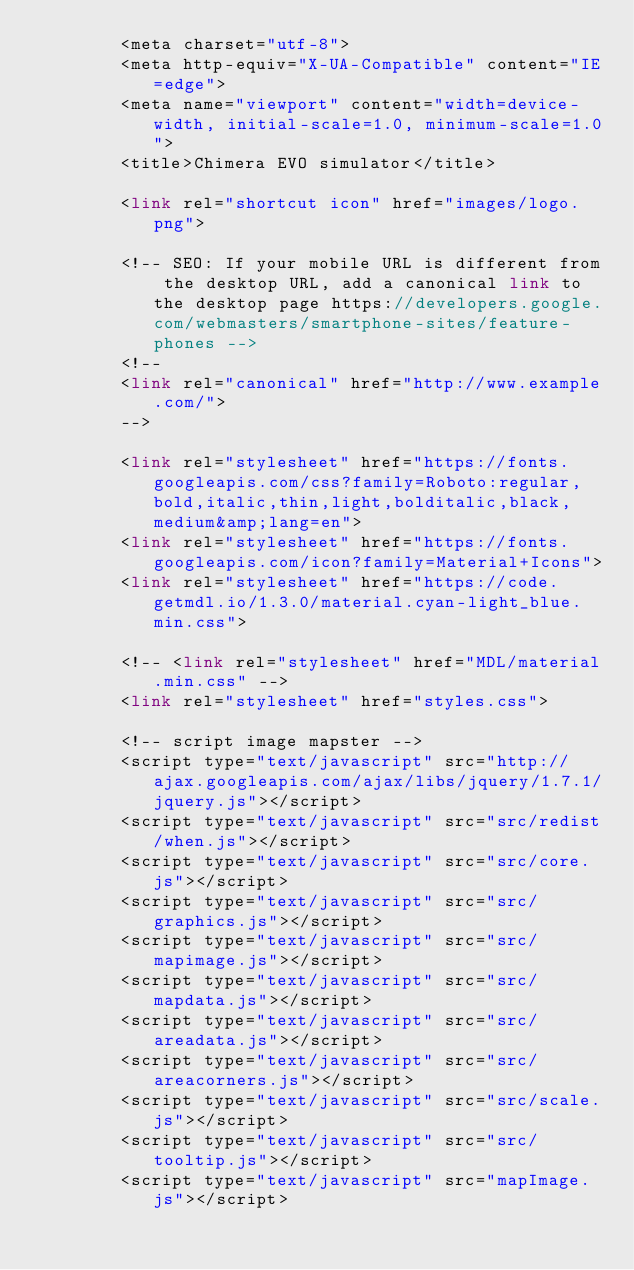Convert code to text. <code><loc_0><loc_0><loc_500><loc_500><_PHP_>        <meta charset="utf-8">
        <meta http-equiv="X-UA-Compatible" content="IE=edge">
        <meta name="viewport" content="width=device-width, initial-scale=1.0, minimum-scale=1.0">
        <title>Chimera EVO simulator</title>

        <link rel="shortcut icon" href="images/logo.png">

        <!-- SEO: If your mobile URL is different from the desktop URL, add a canonical link to the desktop page https://developers.google.com/webmasters/smartphone-sites/feature-phones -->
        <!--
        <link rel="canonical" href="http://www.example.com/">
        -->

        <link rel="stylesheet" href="https://fonts.googleapis.com/css?family=Roboto:regular,bold,italic,thin,light,bolditalic,black,medium&amp;lang=en">
        <link rel="stylesheet" href="https://fonts.googleapis.com/icon?family=Material+Icons">
        <link rel="stylesheet" href="https://code.getmdl.io/1.3.0/material.cyan-light_blue.min.css">

        <!-- <link rel="stylesheet" href="MDL/material.min.css" -->
        <link rel="stylesheet" href="styles.css">
        
        <!-- script image mapster -->
        <script type="text/javascript" src="http://ajax.googleapis.com/ajax/libs/jquery/1.7.1/jquery.js"></script>
        <script type="text/javascript" src="src/redist/when.js"></script>
        <script type="text/javascript" src="src/core.js"></script>
        <script type="text/javascript" src="src/graphics.js"></script>
        <script type="text/javascript" src="src/mapimage.js"></script>
        <script type="text/javascript" src="src/mapdata.js"></script>
        <script type="text/javascript" src="src/areadata.js"></script>
        <script type="text/javascript" src="src/areacorners.js"></script>
        <script type="text/javascript" src="src/scale.js"></script>
        <script type="text/javascript" src="src/tooltip.js"></script>
        <script type="text/javascript" src="mapImage.js"></script></code> 